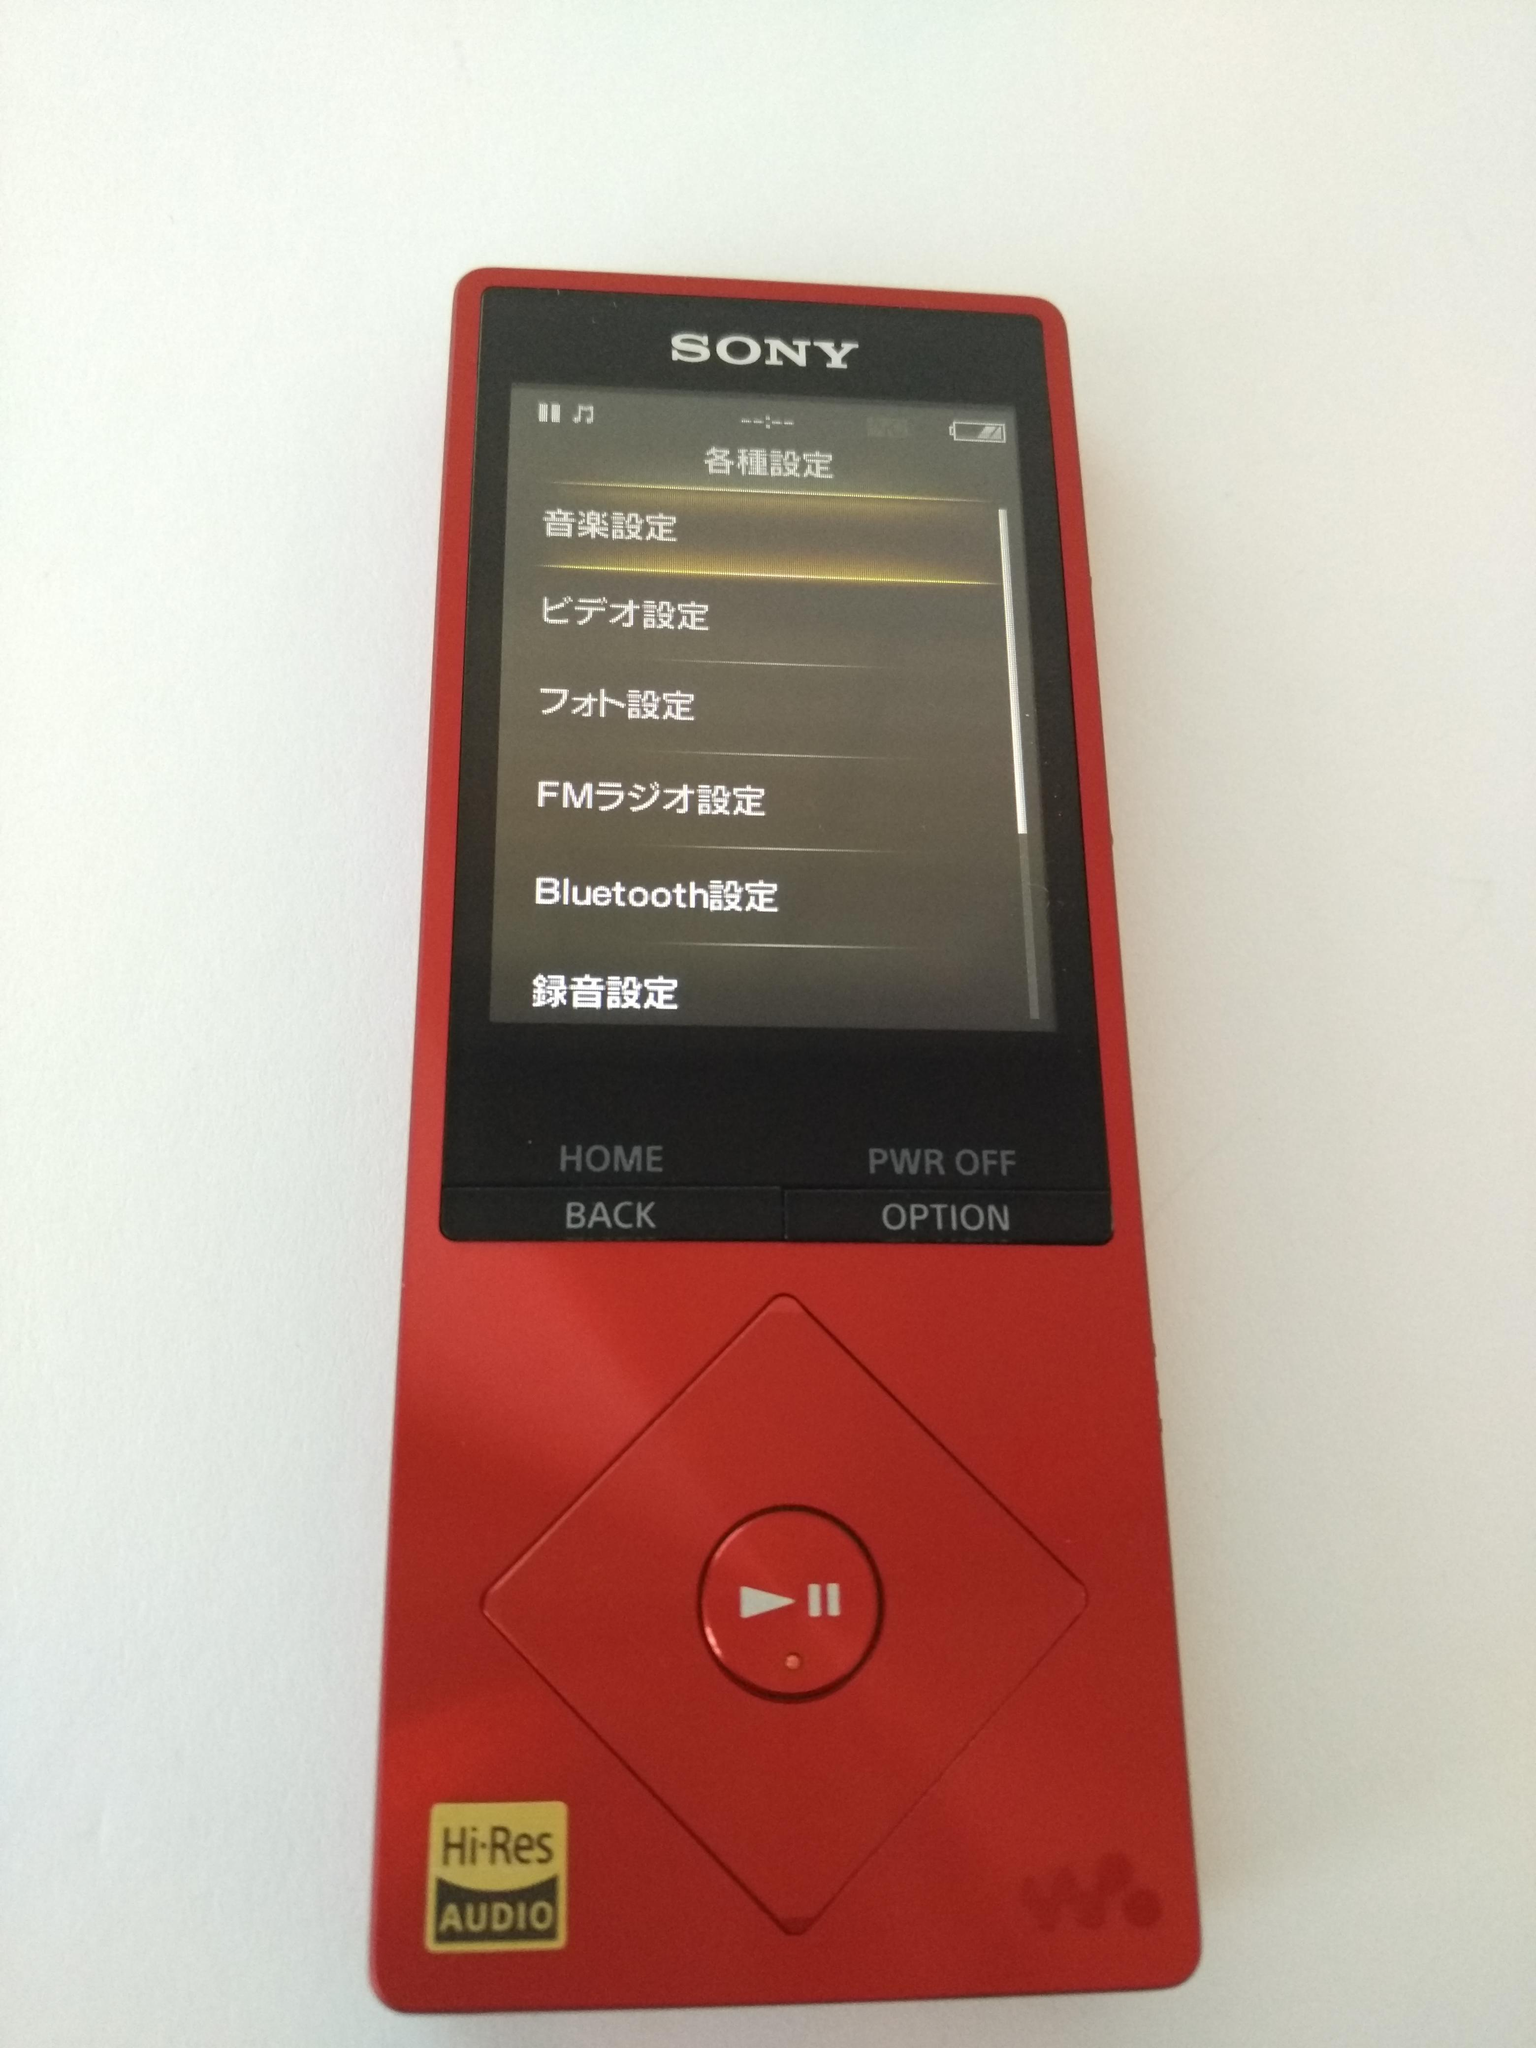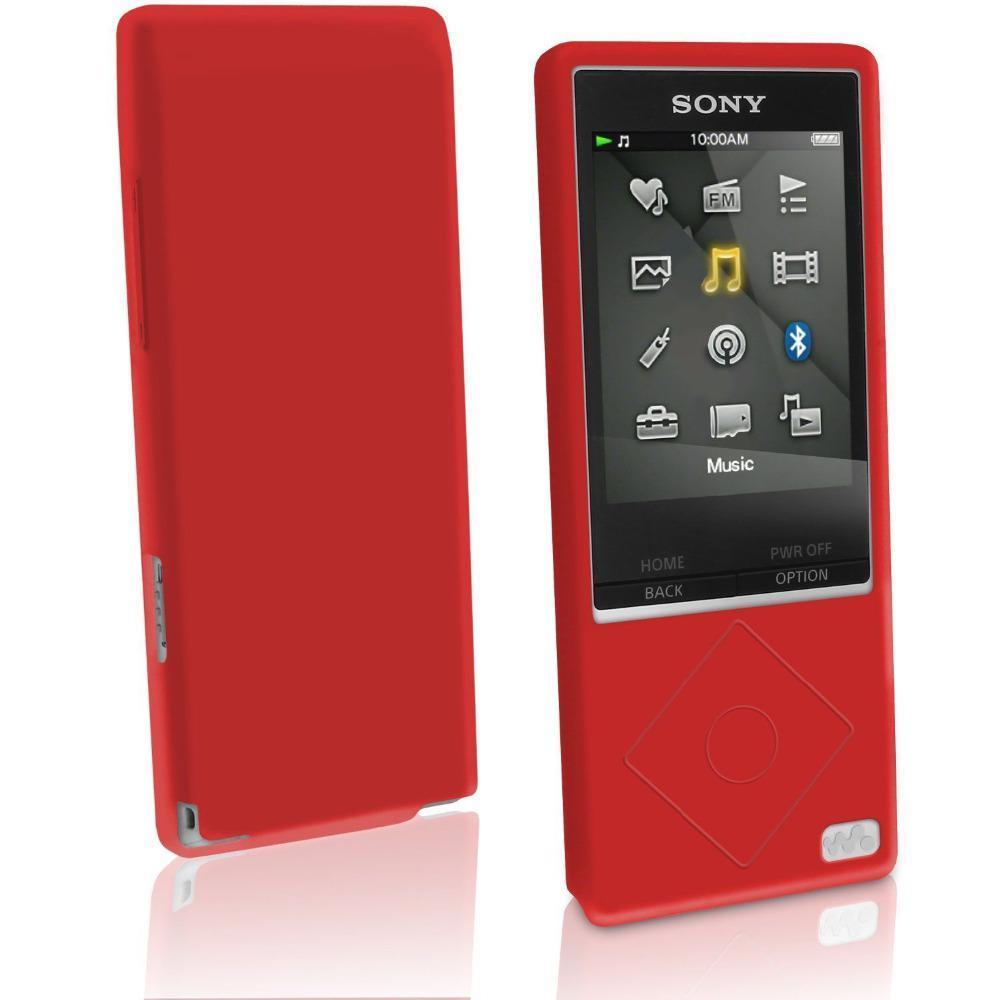The first image is the image on the left, the second image is the image on the right. Evaluate the accuracy of this statement regarding the images: "One image shows the back of the phone.". Is it true? Answer yes or no. Yes. 